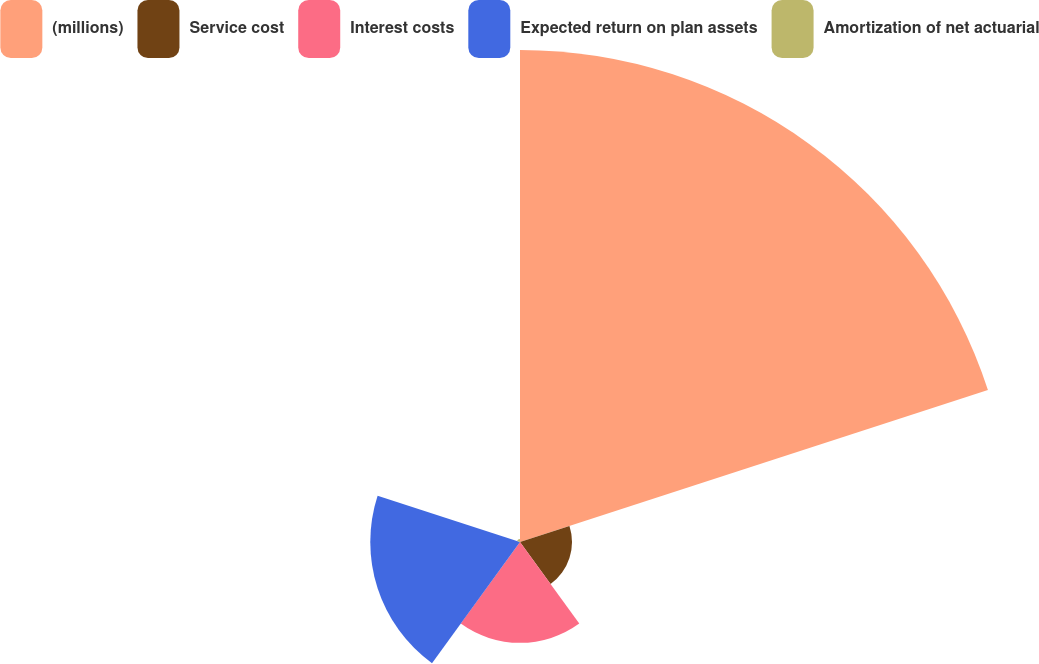Convert chart. <chart><loc_0><loc_0><loc_500><loc_500><pie_chart><fcel>(millions)<fcel>Service cost<fcel>Interest costs<fcel>Expected return on plan assets<fcel>Amortization of net actuarial<nl><fcel>61.68%<fcel>6.52%<fcel>12.64%<fcel>18.77%<fcel>0.39%<nl></chart> 